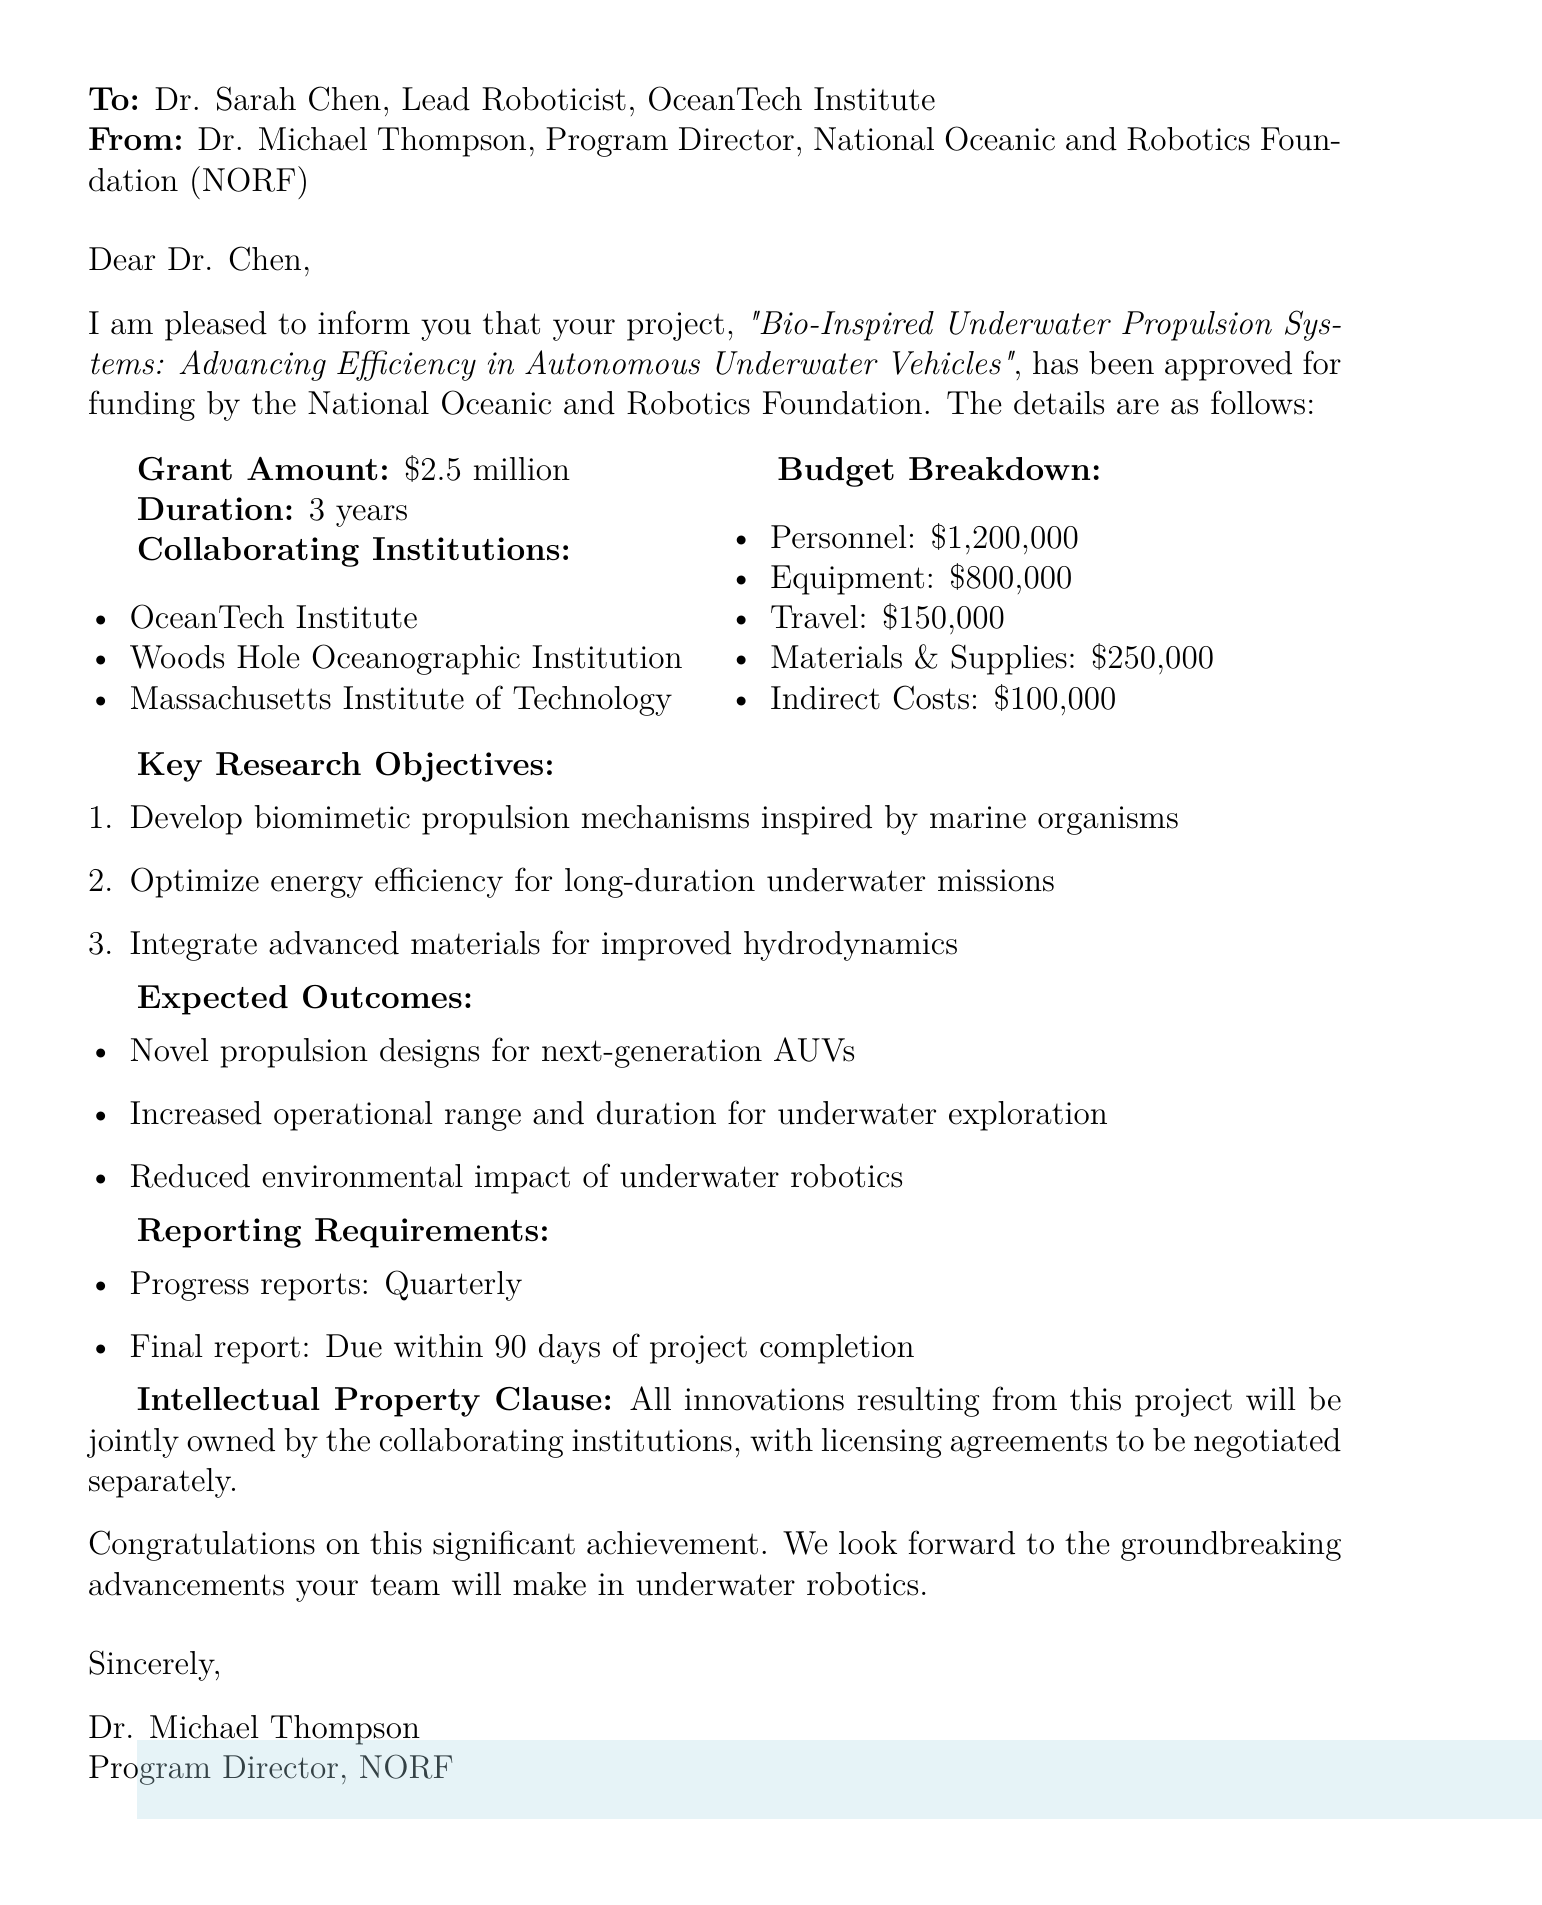What is the grant amount? The grant amount is explicitly stated in the document as $2.5 million.
Answer: $2.5 million Who is the sender of the document? The sender of the document is Dr. Michael Thompson, as mentioned in the "From" section.
Answer: Dr. Michael Thompson How long is the project duration? The project duration is outlined in the document as 3 years.
Answer: 3 years What are the collaborating institutions listed? The document specifies three collaborating institutions, which are OceanTech Institute, Woods Hole Oceanographic Institution, and Massachusetts Institute of Technology.
Answer: OceanTech Institute, Woods Hole Oceanographic Institution, Massachusetts Institute of Technology What is the budget allocation for equipment? The document provides a breakdown, stating that equipment costs will be $800,000.
Answer: $800,000 What are the key research objectives of the project? The document lists three key research objectives, highlighting the focus areas of the project.
Answer: Develop biomimetic propulsion mechanisms inspired by marine organisms, Optimize energy efficiency for long-duration underwater missions, Integrate advanced materials for improved hydrodynamics What is the frequency of progress reports? The frequency of progress reports is detailed in the document as quarterly.
Answer: Quarterly What clause relates to intellectual property? The document specifies that all innovations will be jointly owned by the collaborating institutions.
Answer: Jointly owned by the collaborating institutions What is the title of the project? The title of the project is directly mentioned at the beginning of the document.
Answer: Bio-Inspired Underwater Propulsion Systems: Advancing Efficiency in Autonomous Underwater Vehicles 